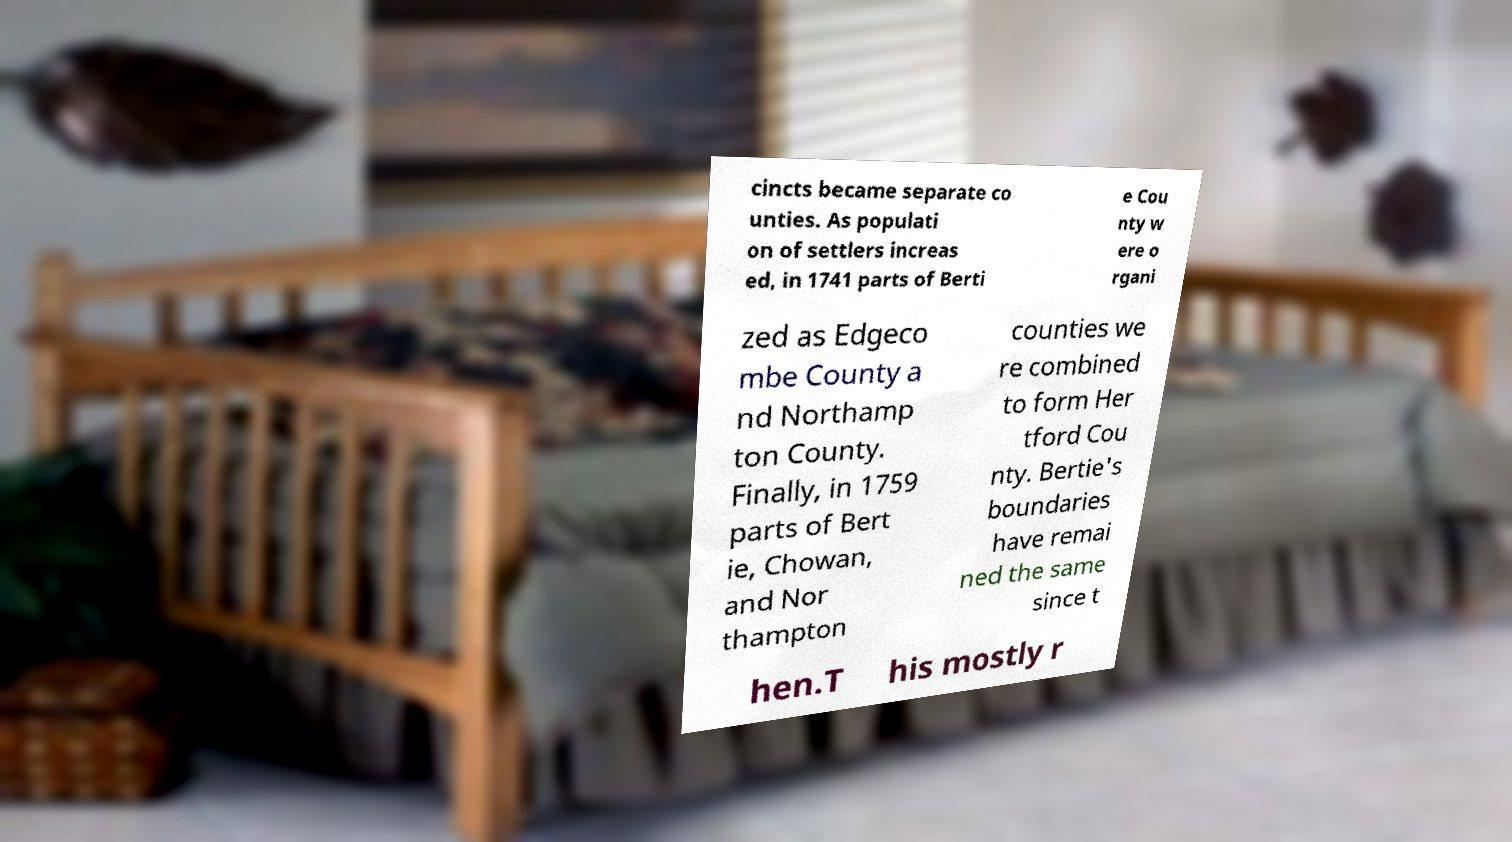Could you assist in decoding the text presented in this image and type it out clearly? cincts became separate co unties. As populati on of settlers increas ed, in 1741 parts of Berti e Cou nty w ere o rgani zed as Edgeco mbe County a nd Northamp ton County. Finally, in 1759 parts of Bert ie, Chowan, and Nor thampton counties we re combined to form Her tford Cou nty. Bertie's boundaries have remai ned the same since t hen.T his mostly r 